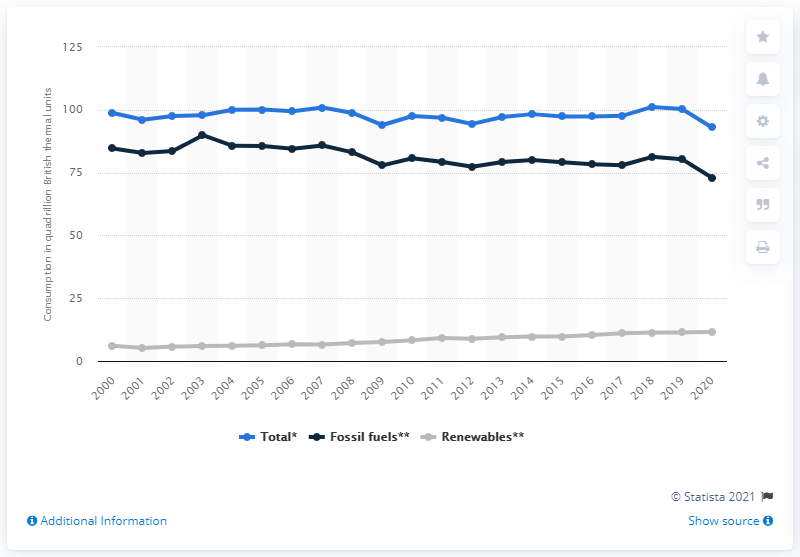Give some essential details in this illustration. In 2020, the amount of fossil fuel consumption in the United States fell to 72.97 quadrillion British thermal units. 